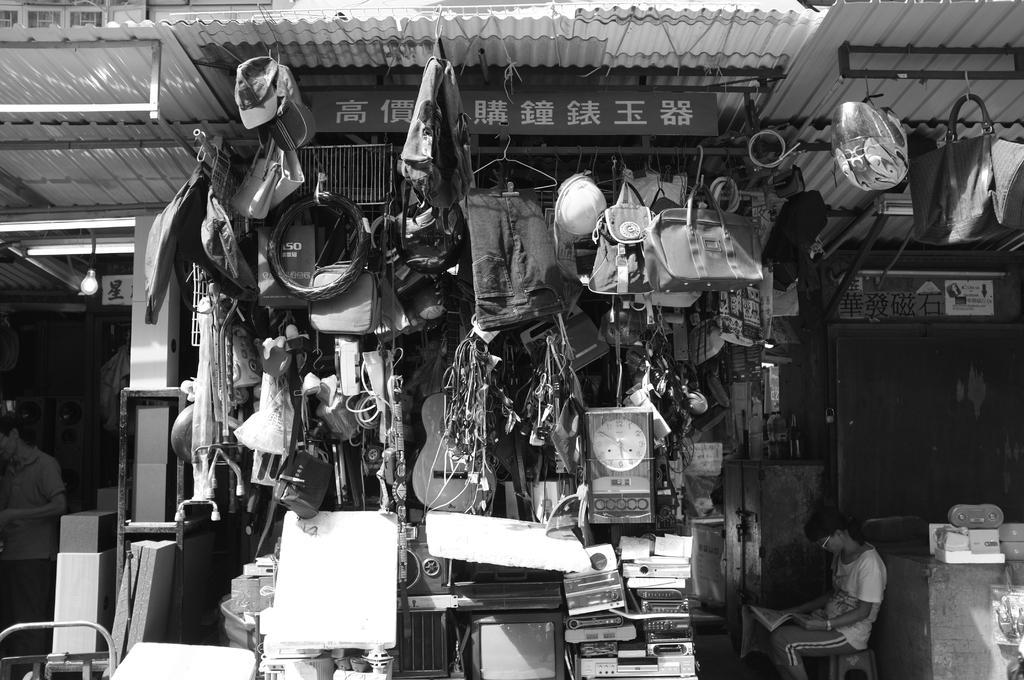Can you describe this image briefly? In this image I can see the black and white picture in which I can see number of objects are hanged. I can see a bag, a helmet, a person standing, a person sitting, a board and few other objects. In the background I can see another building. 